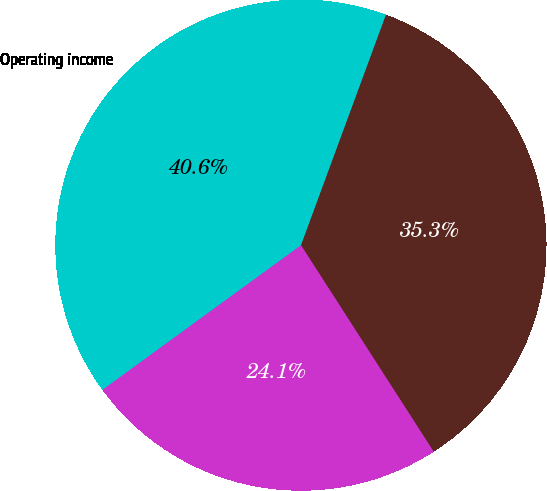<chart> <loc_0><loc_0><loc_500><loc_500><pie_chart><fcel>Cost of sales<fcel>Marketing administration and<fcel>Operating income<nl><fcel>35.29%<fcel>24.07%<fcel>40.64%<nl></chart> 